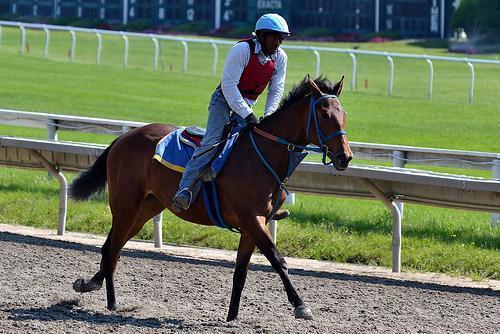How many horses?
Give a very brief answer. 1. 